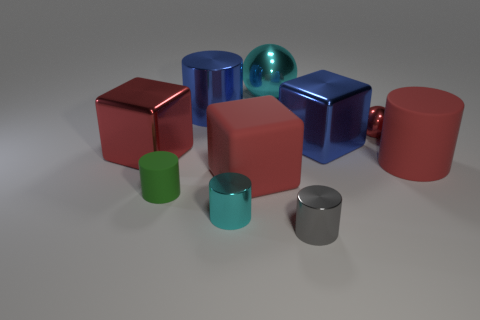Subtract all balls. How many objects are left? 8 Add 2 red matte blocks. How many red matte blocks are left? 3 Add 9 small red objects. How many small red objects exist? 10 Subtract all red blocks. How many blocks are left? 1 Subtract all tiny gray shiny cylinders. How many cylinders are left? 4 Subtract 1 red cylinders. How many objects are left? 9 Subtract 5 cylinders. How many cylinders are left? 0 Subtract all red cylinders. Subtract all gray blocks. How many cylinders are left? 4 Subtract all gray blocks. How many green spheres are left? 0 Subtract all large blue metallic things. Subtract all tiny gray metallic objects. How many objects are left? 7 